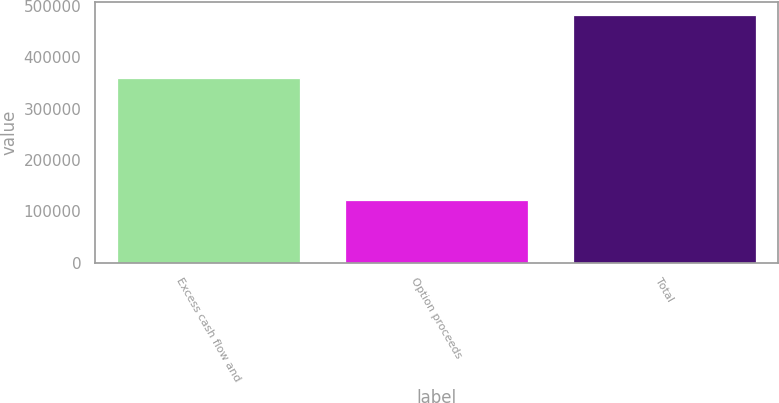Convert chart to OTSL. <chart><loc_0><loc_0><loc_500><loc_500><bar_chart><fcel>Excess cash flow and<fcel>Option proceeds<fcel>Total<nl><fcel>360001<fcel>122263<fcel>482264<nl></chart> 